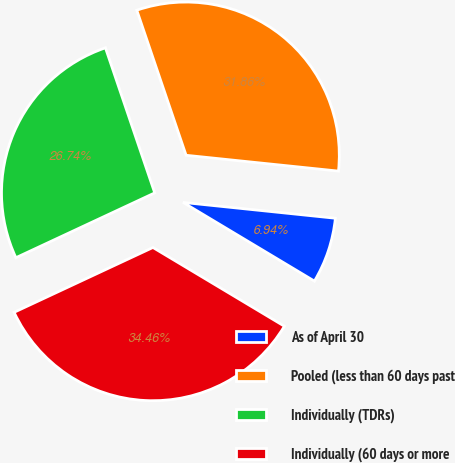Convert chart. <chart><loc_0><loc_0><loc_500><loc_500><pie_chart><fcel>As of April 30<fcel>Pooled (less than 60 days past<fcel>Individually (TDRs)<fcel>Individually (60 days or more<nl><fcel>6.94%<fcel>31.86%<fcel>26.74%<fcel>34.46%<nl></chart> 